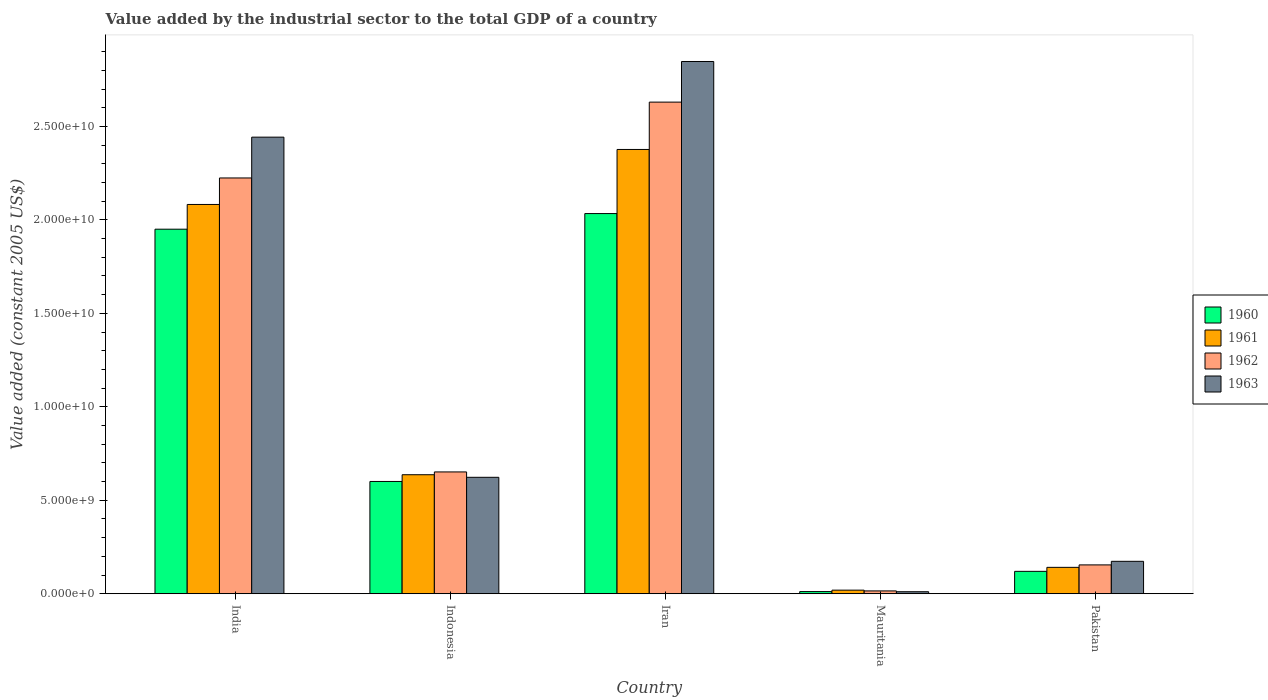Are the number of bars per tick equal to the number of legend labels?
Ensure brevity in your answer.  Yes. Are the number of bars on each tick of the X-axis equal?
Ensure brevity in your answer.  Yes. How many bars are there on the 3rd tick from the left?
Provide a succinct answer. 4. In how many cases, is the number of bars for a given country not equal to the number of legend labels?
Give a very brief answer. 0. What is the value added by the industrial sector in 1962 in India?
Make the answer very short. 2.22e+1. Across all countries, what is the maximum value added by the industrial sector in 1962?
Your response must be concise. 2.63e+1. Across all countries, what is the minimum value added by the industrial sector in 1960?
Keep it short and to the point. 1.15e+08. In which country was the value added by the industrial sector in 1962 maximum?
Keep it short and to the point. Iran. In which country was the value added by the industrial sector in 1960 minimum?
Ensure brevity in your answer.  Mauritania. What is the total value added by the industrial sector in 1961 in the graph?
Offer a very short reply. 5.26e+1. What is the difference between the value added by the industrial sector in 1963 in Mauritania and that in Pakistan?
Provide a short and direct response. -1.63e+09. What is the difference between the value added by the industrial sector in 1962 in India and the value added by the industrial sector in 1963 in Pakistan?
Provide a short and direct response. 2.05e+1. What is the average value added by the industrial sector in 1961 per country?
Your answer should be compact. 1.05e+1. What is the difference between the value added by the industrial sector of/in 1960 and value added by the industrial sector of/in 1962 in Pakistan?
Your answer should be very brief. -3.45e+08. In how many countries, is the value added by the industrial sector in 1963 greater than 1000000000 US$?
Your answer should be very brief. 4. What is the ratio of the value added by the industrial sector in 1963 in Indonesia to that in Pakistan?
Make the answer very short. 3.59. What is the difference between the highest and the second highest value added by the industrial sector in 1961?
Your response must be concise. -2.94e+09. What is the difference between the highest and the lowest value added by the industrial sector in 1961?
Offer a very short reply. 2.36e+1. What does the 4th bar from the right in Indonesia represents?
Provide a short and direct response. 1960. Is it the case that in every country, the sum of the value added by the industrial sector in 1960 and value added by the industrial sector in 1962 is greater than the value added by the industrial sector in 1961?
Give a very brief answer. Yes. Are all the bars in the graph horizontal?
Offer a very short reply. No. How many countries are there in the graph?
Your response must be concise. 5. Does the graph contain any zero values?
Your response must be concise. No. Does the graph contain grids?
Make the answer very short. No. Where does the legend appear in the graph?
Ensure brevity in your answer.  Center right. How many legend labels are there?
Offer a very short reply. 4. What is the title of the graph?
Your response must be concise. Value added by the industrial sector to the total GDP of a country. What is the label or title of the Y-axis?
Offer a very short reply. Value added (constant 2005 US$). What is the Value added (constant 2005 US$) in 1960 in India?
Your response must be concise. 1.95e+1. What is the Value added (constant 2005 US$) of 1961 in India?
Your answer should be compact. 2.08e+1. What is the Value added (constant 2005 US$) of 1962 in India?
Ensure brevity in your answer.  2.22e+1. What is the Value added (constant 2005 US$) in 1963 in India?
Offer a terse response. 2.44e+1. What is the Value added (constant 2005 US$) of 1960 in Indonesia?
Provide a short and direct response. 6.01e+09. What is the Value added (constant 2005 US$) in 1961 in Indonesia?
Keep it short and to the point. 6.37e+09. What is the Value added (constant 2005 US$) in 1962 in Indonesia?
Provide a short and direct response. 6.52e+09. What is the Value added (constant 2005 US$) of 1963 in Indonesia?
Your answer should be very brief. 6.23e+09. What is the Value added (constant 2005 US$) in 1960 in Iran?
Your answer should be compact. 2.03e+1. What is the Value added (constant 2005 US$) in 1961 in Iran?
Provide a short and direct response. 2.38e+1. What is the Value added (constant 2005 US$) of 1962 in Iran?
Your response must be concise. 2.63e+1. What is the Value added (constant 2005 US$) of 1963 in Iran?
Keep it short and to the point. 2.85e+1. What is the Value added (constant 2005 US$) of 1960 in Mauritania?
Make the answer very short. 1.15e+08. What is the Value added (constant 2005 US$) in 1961 in Mauritania?
Your answer should be very brief. 1.92e+08. What is the Value added (constant 2005 US$) of 1962 in Mauritania?
Make the answer very short. 1.51e+08. What is the Value added (constant 2005 US$) in 1963 in Mauritania?
Keep it short and to the point. 1.08e+08. What is the Value added (constant 2005 US$) of 1960 in Pakistan?
Keep it short and to the point. 1.20e+09. What is the Value added (constant 2005 US$) of 1961 in Pakistan?
Make the answer very short. 1.41e+09. What is the Value added (constant 2005 US$) of 1962 in Pakistan?
Offer a very short reply. 1.54e+09. What is the Value added (constant 2005 US$) of 1963 in Pakistan?
Your response must be concise. 1.74e+09. Across all countries, what is the maximum Value added (constant 2005 US$) of 1960?
Offer a very short reply. 2.03e+1. Across all countries, what is the maximum Value added (constant 2005 US$) in 1961?
Your response must be concise. 2.38e+1. Across all countries, what is the maximum Value added (constant 2005 US$) in 1962?
Provide a succinct answer. 2.63e+1. Across all countries, what is the maximum Value added (constant 2005 US$) of 1963?
Provide a short and direct response. 2.85e+1. Across all countries, what is the minimum Value added (constant 2005 US$) in 1960?
Your answer should be compact. 1.15e+08. Across all countries, what is the minimum Value added (constant 2005 US$) in 1961?
Keep it short and to the point. 1.92e+08. Across all countries, what is the minimum Value added (constant 2005 US$) of 1962?
Make the answer very short. 1.51e+08. Across all countries, what is the minimum Value added (constant 2005 US$) of 1963?
Make the answer very short. 1.08e+08. What is the total Value added (constant 2005 US$) in 1960 in the graph?
Provide a short and direct response. 4.72e+1. What is the total Value added (constant 2005 US$) in 1961 in the graph?
Your answer should be compact. 5.26e+1. What is the total Value added (constant 2005 US$) in 1962 in the graph?
Provide a succinct answer. 5.68e+1. What is the total Value added (constant 2005 US$) in 1963 in the graph?
Provide a short and direct response. 6.10e+1. What is the difference between the Value added (constant 2005 US$) in 1960 in India and that in Indonesia?
Provide a short and direct response. 1.35e+1. What is the difference between the Value added (constant 2005 US$) in 1961 in India and that in Indonesia?
Your response must be concise. 1.45e+1. What is the difference between the Value added (constant 2005 US$) in 1962 in India and that in Indonesia?
Your answer should be very brief. 1.57e+1. What is the difference between the Value added (constant 2005 US$) of 1963 in India and that in Indonesia?
Make the answer very short. 1.82e+1. What is the difference between the Value added (constant 2005 US$) of 1960 in India and that in Iran?
Your answer should be compact. -8.36e+08. What is the difference between the Value added (constant 2005 US$) in 1961 in India and that in Iran?
Provide a succinct answer. -2.94e+09. What is the difference between the Value added (constant 2005 US$) in 1962 in India and that in Iran?
Offer a terse response. -4.06e+09. What is the difference between the Value added (constant 2005 US$) of 1963 in India and that in Iran?
Offer a very short reply. -4.05e+09. What is the difference between the Value added (constant 2005 US$) of 1960 in India and that in Mauritania?
Your answer should be compact. 1.94e+1. What is the difference between the Value added (constant 2005 US$) in 1961 in India and that in Mauritania?
Your answer should be compact. 2.06e+1. What is the difference between the Value added (constant 2005 US$) in 1962 in India and that in Mauritania?
Give a very brief answer. 2.21e+1. What is the difference between the Value added (constant 2005 US$) of 1963 in India and that in Mauritania?
Ensure brevity in your answer.  2.43e+1. What is the difference between the Value added (constant 2005 US$) in 1960 in India and that in Pakistan?
Ensure brevity in your answer.  1.83e+1. What is the difference between the Value added (constant 2005 US$) of 1961 in India and that in Pakistan?
Your answer should be compact. 1.94e+1. What is the difference between the Value added (constant 2005 US$) in 1962 in India and that in Pakistan?
Ensure brevity in your answer.  2.07e+1. What is the difference between the Value added (constant 2005 US$) in 1963 in India and that in Pakistan?
Your response must be concise. 2.27e+1. What is the difference between the Value added (constant 2005 US$) in 1960 in Indonesia and that in Iran?
Make the answer very short. -1.43e+1. What is the difference between the Value added (constant 2005 US$) of 1961 in Indonesia and that in Iran?
Ensure brevity in your answer.  -1.74e+1. What is the difference between the Value added (constant 2005 US$) in 1962 in Indonesia and that in Iran?
Ensure brevity in your answer.  -1.98e+1. What is the difference between the Value added (constant 2005 US$) in 1963 in Indonesia and that in Iran?
Your answer should be very brief. -2.22e+1. What is the difference between the Value added (constant 2005 US$) of 1960 in Indonesia and that in Mauritania?
Keep it short and to the point. 5.89e+09. What is the difference between the Value added (constant 2005 US$) in 1961 in Indonesia and that in Mauritania?
Give a very brief answer. 6.17e+09. What is the difference between the Value added (constant 2005 US$) of 1962 in Indonesia and that in Mauritania?
Keep it short and to the point. 6.37e+09. What is the difference between the Value added (constant 2005 US$) of 1963 in Indonesia and that in Mauritania?
Your answer should be very brief. 6.12e+09. What is the difference between the Value added (constant 2005 US$) in 1960 in Indonesia and that in Pakistan?
Ensure brevity in your answer.  4.81e+09. What is the difference between the Value added (constant 2005 US$) of 1961 in Indonesia and that in Pakistan?
Keep it short and to the point. 4.96e+09. What is the difference between the Value added (constant 2005 US$) of 1962 in Indonesia and that in Pakistan?
Keep it short and to the point. 4.97e+09. What is the difference between the Value added (constant 2005 US$) in 1963 in Indonesia and that in Pakistan?
Ensure brevity in your answer.  4.49e+09. What is the difference between the Value added (constant 2005 US$) in 1960 in Iran and that in Mauritania?
Give a very brief answer. 2.02e+1. What is the difference between the Value added (constant 2005 US$) of 1961 in Iran and that in Mauritania?
Ensure brevity in your answer.  2.36e+1. What is the difference between the Value added (constant 2005 US$) of 1962 in Iran and that in Mauritania?
Your answer should be very brief. 2.62e+1. What is the difference between the Value added (constant 2005 US$) of 1963 in Iran and that in Mauritania?
Offer a terse response. 2.84e+1. What is the difference between the Value added (constant 2005 US$) of 1960 in Iran and that in Pakistan?
Ensure brevity in your answer.  1.91e+1. What is the difference between the Value added (constant 2005 US$) of 1961 in Iran and that in Pakistan?
Give a very brief answer. 2.24e+1. What is the difference between the Value added (constant 2005 US$) in 1962 in Iran and that in Pakistan?
Your answer should be very brief. 2.48e+1. What is the difference between the Value added (constant 2005 US$) of 1963 in Iran and that in Pakistan?
Provide a succinct answer. 2.67e+1. What is the difference between the Value added (constant 2005 US$) of 1960 in Mauritania and that in Pakistan?
Offer a very short reply. -1.08e+09. What is the difference between the Value added (constant 2005 US$) of 1961 in Mauritania and that in Pakistan?
Your response must be concise. -1.22e+09. What is the difference between the Value added (constant 2005 US$) in 1962 in Mauritania and that in Pakistan?
Make the answer very short. -1.39e+09. What is the difference between the Value added (constant 2005 US$) in 1963 in Mauritania and that in Pakistan?
Your response must be concise. -1.63e+09. What is the difference between the Value added (constant 2005 US$) of 1960 in India and the Value added (constant 2005 US$) of 1961 in Indonesia?
Provide a succinct answer. 1.31e+1. What is the difference between the Value added (constant 2005 US$) in 1960 in India and the Value added (constant 2005 US$) in 1962 in Indonesia?
Offer a very short reply. 1.30e+1. What is the difference between the Value added (constant 2005 US$) in 1960 in India and the Value added (constant 2005 US$) in 1963 in Indonesia?
Make the answer very short. 1.33e+1. What is the difference between the Value added (constant 2005 US$) of 1961 in India and the Value added (constant 2005 US$) of 1962 in Indonesia?
Provide a succinct answer. 1.43e+1. What is the difference between the Value added (constant 2005 US$) of 1961 in India and the Value added (constant 2005 US$) of 1963 in Indonesia?
Make the answer very short. 1.46e+1. What is the difference between the Value added (constant 2005 US$) in 1962 in India and the Value added (constant 2005 US$) in 1963 in Indonesia?
Your answer should be very brief. 1.60e+1. What is the difference between the Value added (constant 2005 US$) of 1960 in India and the Value added (constant 2005 US$) of 1961 in Iran?
Provide a short and direct response. -4.27e+09. What is the difference between the Value added (constant 2005 US$) in 1960 in India and the Value added (constant 2005 US$) in 1962 in Iran?
Provide a short and direct response. -6.80e+09. What is the difference between the Value added (constant 2005 US$) of 1960 in India and the Value added (constant 2005 US$) of 1963 in Iran?
Make the answer very short. -8.97e+09. What is the difference between the Value added (constant 2005 US$) of 1961 in India and the Value added (constant 2005 US$) of 1962 in Iran?
Your answer should be very brief. -5.48e+09. What is the difference between the Value added (constant 2005 US$) in 1961 in India and the Value added (constant 2005 US$) in 1963 in Iran?
Your response must be concise. -7.65e+09. What is the difference between the Value added (constant 2005 US$) of 1962 in India and the Value added (constant 2005 US$) of 1963 in Iran?
Offer a very short reply. -6.23e+09. What is the difference between the Value added (constant 2005 US$) in 1960 in India and the Value added (constant 2005 US$) in 1961 in Mauritania?
Your answer should be very brief. 1.93e+1. What is the difference between the Value added (constant 2005 US$) of 1960 in India and the Value added (constant 2005 US$) of 1962 in Mauritania?
Give a very brief answer. 1.94e+1. What is the difference between the Value added (constant 2005 US$) in 1960 in India and the Value added (constant 2005 US$) in 1963 in Mauritania?
Offer a terse response. 1.94e+1. What is the difference between the Value added (constant 2005 US$) in 1961 in India and the Value added (constant 2005 US$) in 1962 in Mauritania?
Offer a terse response. 2.07e+1. What is the difference between the Value added (constant 2005 US$) in 1961 in India and the Value added (constant 2005 US$) in 1963 in Mauritania?
Offer a terse response. 2.07e+1. What is the difference between the Value added (constant 2005 US$) in 1962 in India and the Value added (constant 2005 US$) in 1963 in Mauritania?
Make the answer very short. 2.21e+1. What is the difference between the Value added (constant 2005 US$) of 1960 in India and the Value added (constant 2005 US$) of 1961 in Pakistan?
Ensure brevity in your answer.  1.81e+1. What is the difference between the Value added (constant 2005 US$) in 1960 in India and the Value added (constant 2005 US$) in 1962 in Pakistan?
Offer a very short reply. 1.80e+1. What is the difference between the Value added (constant 2005 US$) in 1960 in India and the Value added (constant 2005 US$) in 1963 in Pakistan?
Keep it short and to the point. 1.78e+1. What is the difference between the Value added (constant 2005 US$) of 1961 in India and the Value added (constant 2005 US$) of 1962 in Pakistan?
Make the answer very short. 1.93e+1. What is the difference between the Value added (constant 2005 US$) of 1961 in India and the Value added (constant 2005 US$) of 1963 in Pakistan?
Ensure brevity in your answer.  1.91e+1. What is the difference between the Value added (constant 2005 US$) in 1962 in India and the Value added (constant 2005 US$) in 1963 in Pakistan?
Your answer should be very brief. 2.05e+1. What is the difference between the Value added (constant 2005 US$) in 1960 in Indonesia and the Value added (constant 2005 US$) in 1961 in Iran?
Make the answer very short. -1.78e+1. What is the difference between the Value added (constant 2005 US$) of 1960 in Indonesia and the Value added (constant 2005 US$) of 1962 in Iran?
Your answer should be very brief. -2.03e+1. What is the difference between the Value added (constant 2005 US$) in 1960 in Indonesia and the Value added (constant 2005 US$) in 1963 in Iran?
Ensure brevity in your answer.  -2.25e+1. What is the difference between the Value added (constant 2005 US$) of 1961 in Indonesia and the Value added (constant 2005 US$) of 1962 in Iran?
Offer a terse response. -1.99e+1. What is the difference between the Value added (constant 2005 US$) of 1961 in Indonesia and the Value added (constant 2005 US$) of 1963 in Iran?
Make the answer very short. -2.21e+1. What is the difference between the Value added (constant 2005 US$) of 1962 in Indonesia and the Value added (constant 2005 US$) of 1963 in Iran?
Offer a terse response. -2.20e+1. What is the difference between the Value added (constant 2005 US$) in 1960 in Indonesia and the Value added (constant 2005 US$) in 1961 in Mauritania?
Ensure brevity in your answer.  5.81e+09. What is the difference between the Value added (constant 2005 US$) of 1960 in Indonesia and the Value added (constant 2005 US$) of 1962 in Mauritania?
Provide a succinct answer. 5.86e+09. What is the difference between the Value added (constant 2005 US$) in 1960 in Indonesia and the Value added (constant 2005 US$) in 1963 in Mauritania?
Your response must be concise. 5.90e+09. What is the difference between the Value added (constant 2005 US$) in 1961 in Indonesia and the Value added (constant 2005 US$) in 1962 in Mauritania?
Ensure brevity in your answer.  6.22e+09. What is the difference between the Value added (constant 2005 US$) of 1961 in Indonesia and the Value added (constant 2005 US$) of 1963 in Mauritania?
Provide a short and direct response. 6.26e+09. What is the difference between the Value added (constant 2005 US$) in 1962 in Indonesia and the Value added (constant 2005 US$) in 1963 in Mauritania?
Provide a short and direct response. 6.41e+09. What is the difference between the Value added (constant 2005 US$) in 1960 in Indonesia and the Value added (constant 2005 US$) in 1961 in Pakistan?
Your response must be concise. 4.60e+09. What is the difference between the Value added (constant 2005 US$) of 1960 in Indonesia and the Value added (constant 2005 US$) of 1962 in Pakistan?
Give a very brief answer. 4.46e+09. What is the difference between the Value added (constant 2005 US$) in 1960 in Indonesia and the Value added (constant 2005 US$) in 1963 in Pakistan?
Your response must be concise. 4.27e+09. What is the difference between the Value added (constant 2005 US$) of 1961 in Indonesia and the Value added (constant 2005 US$) of 1962 in Pakistan?
Give a very brief answer. 4.82e+09. What is the difference between the Value added (constant 2005 US$) in 1961 in Indonesia and the Value added (constant 2005 US$) in 1963 in Pakistan?
Give a very brief answer. 4.63e+09. What is the difference between the Value added (constant 2005 US$) of 1962 in Indonesia and the Value added (constant 2005 US$) of 1963 in Pakistan?
Give a very brief answer. 4.78e+09. What is the difference between the Value added (constant 2005 US$) in 1960 in Iran and the Value added (constant 2005 US$) in 1961 in Mauritania?
Provide a succinct answer. 2.01e+1. What is the difference between the Value added (constant 2005 US$) of 1960 in Iran and the Value added (constant 2005 US$) of 1962 in Mauritania?
Ensure brevity in your answer.  2.02e+1. What is the difference between the Value added (constant 2005 US$) in 1960 in Iran and the Value added (constant 2005 US$) in 1963 in Mauritania?
Offer a very short reply. 2.02e+1. What is the difference between the Value added (constant 2005 US$) in 1961 in Iran and the Value added (constant 2005 US$) in 1962 in Mauritania?
Provide a succinct answer. 2.36e+1. What is the difference between the Value added (constant 2005 US$) of 1961 in Iran and the Value added (constant 2005 US$) of 1963 in Mauritania?
Your answer should be compact. 2.37e+1. What is the difference between the Value added (constant 2005 US$) of 1962 in Iran and the Value added (constant 2005 US$) of 1963 in Mauritania?
Keep it short and to the point. 2.62e+1. What is the difference between the Value added (constant 2005 US$) in 1960 in Iran and the Value added (constant 2005 US$) in 1961 in Pakistan?
Keep it short and to the point. 1.89e+1. What is the difference between the Value added (constant 2005 US$) in 1960 in Iran and the Value added (constant 2005 US$) in 1962 in Pakistan?
Your response must be concise. 1.88e+1. What is the difference between the Value added (constant 2005 US$) of 1960 in Iran and the Value added (constant 2005 US$) of 1963 in Pakistan?
Make the answer very short. 1.86e+1. What is the difference between the Value added (constant 2005 US$) in 1961 in Iran and the Value added (constant 2005 US$) in 1962 in Pakistan?
Give a very brief answer. 2.22e+1. What is the difference between the Value added (constant 2005 US$) in 1961 in Iran and the Value added (constant 2005 US$) in 1963 in Pakistan?
Make the answer very short. 2.20e+1. What is the difference between the Value added (constant 2005 US$) in 1962 in Iran and the Value added (constant 2005 US$) in 1963 in Pakistan?
Offer a terse response. 2.46e+1. What is the difference between the Value added (constant 2005 US$) in 1960 in Mauritania and the Value added (constant 2005 US$) in 1961 in Pakistan?
Keep it short and to the point. -1.30e+09. What is the difference between the Value added (constant 2005 US$) of 1960 in Mauritania and the Value added (constant 2005 US$) of 1962 in Pakistan?
Offer a terse response. -1.43e+09. What is the difference between the Value added (constant 2005 US$) of 1960 in Mauritania and the Value added (constant 2005 US$) of 1963 in Pakistan?
Provide a short and direct response. -1.62e+09. What is the difference between the Value added (constant 2005 US$) of 1961 in Mauritania and the Value added (constant 2005 US$) of 1962 in Pakistan?
Provide a succinct answer. -1.35e+09. What is the difference between the Value added (constant 2005 US$) of 1961 in Mauritania and the Value added (constant 2005 US$) of 1963 in Pakistan?
Offer a terse response. -1.54e+09. What is the difference between the Value added (constant 2005 US$) of 1962 in Mauritania and the Value added (constant 2005 US$) of 1963 in Pakistan?
Keep it short and to the point. -1.58e+09. What is the average Value added (constant 2005 US$) of 1960 per country?
Provide a short and direct response. 9.43e+09. What is the average Value added (constant 2005 US$) of 1961 per country?
Offer a terse response. 1.05e+1. What is the average Value added (constant 2005 US$) in 1962 per country?
Give a very brief answer. 1.14e+1. What is the average Value added (constant 2005 US$) in 1963 per country?
Provide a short and direct response. 1.22e+1. What is the difference between the Value added (constant 2005 US$) of 1960 and Value added (constant 2005 US$) of 1961 in India?
Offer a very short reply. -1.32e+09. What is the difference between the Value added (constant 2005 US$) in 1960 and Value added (constant 2005 US$) in 1962 in India?
Keep it short and to the point. -2.74e+09. What is the difference between the Value added (constant 2005 US$) in 1960 and Value added (constant 2005 US$) in 1963 in India?
Give a very brief answer. -4.92e+09. What is the difference between the Value added (constant 2005 US$) of 1961 and Value added (constant 2005 US$) of 1962 in India?
Give a very brief answer. -1.42e+09. What is the difference between the Value added (constant 2005 US$) of 1961 and Value added (constant 2005 US$) of 1963 in India?
Keep it short and to the point. -3.60e+09. What is the difference between the Value added (constant 2005 US$) of 1962 and Value added (constant 2005 US$) of 1963 in India?
Provide a succinct answer. -2.18e+09. What is the difference between the Value added (constant 2005 US$) of 1960 and Value added (constant 2005 US$) of 1961 in Indonesia?
Keep it short and to the point. -3.60e+08. What is the difference between the Value added (constant 2005 US$) of 1960 and Value added (constant 2005 US$) of 1962 in Indonesia?
Offer a very short reply. -5.10e+08. What is the difference between the Value added (constant 2005 US$) in 1960 and Value added (constant 2005 US$) in 1963 in Indonesia?
Your answer should be very brief. -2.22e+08. What is the difference between the Value added (constant 2005 US$) in 1961 and Value added (constant 2005 US$) in 1962 in Indonesia?
Offer a very short reply. -1.50e+08. What is the difference between the Value added (constant 2005 US$) of 1961 and Value added (constant 2005 US$) of 1963 in Indonesia?
Your answer should be compact. 1.38e+08. What is the difference between the Value added (constant 2005 US$) of 1962 and Value added (constant 2005 US$) of 1963 in Indonesia?
Give a very brief answer. 2.88e+08. What is the difference between the Value added (constant 2005 US$) in 1960 and Value added (constant 2005 US$) in 1961 in Iran?
Give a very brief answer. -3.43e+09. What is the difference between the Value added (constant 2005 US$) of 1960 and Value added (constant 2005 US$) of 1962 in Iran?
Provide a succinct answer. -5.96e+09. What is the difference between the Value added (constant 2005 US$) of 1960 and Value added (constant 2005 US$) of 1963 in Iran?
Provide a short and direct response. -8.14e+09. What is the difference between the Value added (constant 2005 US$) in 1961 and Value added (constant 2005 US$) in 1962 in Iran?
Make the answer very short. -2.53e+09. What is the difference between the Value added (constant 2005 US$) of 1961 and Value added (constant 2005 US$) of 1963 in Iran?
Your response must be concise. -4.71e+09. What is the difference between the Value added (constant 2005 US$) of 1962 and Value added (constant 2005 US$) of 1963 in Iran?
Ensure brevity in your answer.  -2.17e+09. What is the difference between the Value added (constant 2005 US$) of 1960 and Value added (constant 2005 US$) of 1961 in Mauritania?
Keep it short and to the point. -7.68e+07. What is the difference between the Value added (constant 2005 US$) of 1960 and Value added (constant 2005 US$) of 1962 in Mauritania?
Give a very brief answer. -3.59e+07. What is the difference between the Value added (constant 2005 US$) of 1960 and Value added (constant 2005 US$) of 1963 in Mauritania?
Ensure brevity in your answer.  7.13e+06. What is the difference between the Value added (constant 2005 US$) in 1961 and Value added (constant 2005 US$) in 1962 in Mauritania?
Your answer should be very brief. 4.09e+07. What is the difference between the Value added (constant 2005 US$) of 1961 and Value added (constant 2005 US$) of 1963 in Mauritania?
Offer a terse response. 8.39e+07. What is the difference between the Value added (constant 2005 US$) in 1962 and Value added (constant 2005 US$) in 1963 in Mauritania?
Offer a very short reply. 4.31e+07. What is the difference between the Value added (constant 2005 US$) of 1960 and Value added (constant 2005 US$) of 1961 in Pakistan?
Provide a succinct answer. -2.14e+08. What is the difference between the Value added (constant 2005 US$) in 1960 and Value added (constant 2005 US$) in 1962 in Pakistan?
Provide a succinct answer. -3.45e+08. What is the difference between the Value added (constant 2005 US$) of 1960 and Value added (constant 2005 US$) of 1963 in Pakistan?
Offer a terse response. -5.37e+08. What is the difference between the Value added (constant 2005 US$) of 1961 and Value added (constant 2005 US$) of 1962 in Pakistan?
Your response must be concise. -1.32e+08. What is the difference between the Value added (constant 2005 US$) of 1961 and Value added (constant 2005 US$) of 1963 in Pakistan?
Provide a succinct answer. -3.23e+08. What is the difference between the Value added (constant 2005 US$) in 1962 and Value added (constant 2005 US$) in 1963 in Pakistan?
Give a very brief answer. -1.92e+08. What is the ratio of the Value added (constant 2005 US$) of 1960 in India to that in Indonesia?
Offer a very short reply. 3.25. What is the ratio of the Value added (constant 2005 US$) of 1961 in India to that in Indonesia?
Make the answer very short. 3.27. What is the ratio of the Value added (constant 2005 US$) in 1962 in India to that in Indonesia?
Your answer should be compact. 3.41. What is the ratio of the Value added (constant 2005 US$) of 1963 in India to that in Indonesia?
Make the answer very short. 3.92. What is the ratio of the Value added (constant 2005 US$) of 1960 in India to that in Iran?
Ensure brevity in your answer.  0.96. What is the ratio of the Value added (constant 2005 US$) of 1961 in India to that in Iran?
Ensure brevity in your answer.  0.88. What is the ratio of the Value added (constant 2005 US$) in 1962 in India to that in Iran?
Provide a succinct answer. 0.85. What is the ratio of the Value added (constant 2005 US$) in 1963 in India to that in Iran?
Offer a very short reply. 0.86. What is the ratio of the Value added (constant 2005 US$) of 1960 in India to that in Mauritania?
Offer a terse response. 169.07. What is the ratio of the Value added (constant 2005 US$) of 1961 in India to that in Mauritania?
Provide a short and direct response. 108.39. What is the ratio of the Value added (constant 2005 US$) in 1962 in India to that in Mauritania?
Provide a short and direct response. 147.02. What is the ratio of the Value added (constant 2005 US$) in 1963 in India to that in Mauritania?
Ensure brevity in your answer.  225.7. What is the ratio of the Value added (constant 2005 US$) in 1960 in India to that in Pakistan?
Give a very brief answer. 16.28. What is the ratio of the Value added (constant 2005 US$) of 1961 in India to that in Pakistan?
Ensure brevity in your answer.  14.75. What is the ratio of the Value added (constant 2005 US$) in 1962 in India to that in Pakistan?
Provide a short and direct response. 14.41. What is the ratio of the Value added (constant 2005 US$) in 1963 in India to that in Pakistan?
Offer a terse response. 14.08. What is the ratio of the Value added (constant 2005 US$) in 1960 in Indonesia to that in Iran?
Offer a very short reply. 0.3. What is the ratio of the Value added (constant 2005 US$) in 1961 in Indonesia to that in Iran?
Your answer should be very brief. 0.27. What is the ratio of the Value added (constant 2005 US$) of 1962 in Indonesia to that in Iran?
Keep it short and to the point. 0.25. What is the ratio of the Value added (constant 2005 US$) of 1963 in Indonesia to that in Iran?
Keep it short and to the point. 0.22. What is the ratio of the Value added (constant 2005 US$) in 1960 in Indonesia to that in Mauritania?
Give a very brief answer. 52.07. What is the ratio of the Value added (constant 2005 US$) in 1961 in Indonesia to that in Mauritania?
Offer a very short reply. 33.14. What is the ratio of the Value added (constant 2005 US$) of 1962 in Indonesia to that in Mauritania?
Offer a terse response. 43.07. What is the ratio of the Value added (constant 2005 US$) in 1963 in Indonesia to that in Mauritania?
Make the answer very short. 57.56. What is the ratio of the Value added (constant 2005 US$) of 1960 in Indonesia to that in Pakistan?
Provide a short and direct response. 5.01. What is the ratio of the Value added (constant 2005 US$) in 1961 in Indonesia to that in Pakistan?
Make the answer very short. 4.51. What is the ratio of the Value added (constant 2005 US$) of 1962 in Indonesia to that in Pakistan?
Your answer should be very brief. 4.22. What is the ratio of the Value added (constant 2005 US$) of 1963 in Indonesia to that in Pakistan?
Make the answer very short. 3.59. What is the ratio of the Value added (constant 2005 US$) of 1960 in Iran to that in Mauritania?
Your answer should be very brief. 176.32. What is the ratio of the Value added (constant 2005 US$) in 1961 in Iran to that in Mauritania?
Your answer should be very brief. 123.7. What is the ratio of the Value added (constant 2005 US$) of 1962 in Iran to that in Mauritania?
Your answer should be compact. 173.84. What is the ratio of the Value added (constant 2005 US$) in 1963 in Iran to that in Mauritania?
Keep it short and to the point. 263.11. What is the ratio of the Value added (constant 2005 US$) in 1960 in Iran to that in Pakistan?
Provide a short and direct response. 16.98. What is the ratio of the Value added (constant 2005 US$) of 1961 in Iran to that in Pakistan?
Your response must be concise. 16.84. What is the ratio of the Value added (constant 2005 US$) of 1962 in Iran to that in Pakistan?
Your response must be concise. 17.04. What is the ratio of the Value added (constant 2005 US$) in 1963 in Iran to that in Pakistan?
Your answer should be compact. 16.41. What is the ratio of the Value added (constant 2005 US$) in 1960 in Mauritania to that in Pakistan?
Keep it short and to the point. 0.1. What is the ratio of the Value added (constant 2005 US$) in 1961 in Mauritania to that in Pakistan?
Make the answer very short. 0.14. What is the ratio of the Value added (constant 2005 US$) of 1962 in Mauritania to that in Pakistan?
Provide a short and direct response. 0.1. What is the ratio of the Value added (constant 2005 US$) of 1963 in Mauritania to that in Pakistan?
Your answer should be compact. 0.06. What is the difference between the highest and the second highest Value added (constant 2005 US$) in 1960?
Your response must be concise. 8.36e+08. What is the difference between the highest and the second highest Value added (constant 2005 US$) in 1961?
Your response must be concise. 2.94e+09. What is the difference between the highest and the second highest Value added (constant 2005 US$) in 1962?
Offer a very short reply. 4.06e+09. What is the difference between the highest and the second highest Value added (constant 2005 US$) in 1963?
Provide a succinct answer. 4.05e+09. What is the difference between the highest and the lowest Value added (constant 2005 US$) of 1960?
Keep it short and to the point. 2.02e+1. What is the difference between the highest and the lowest Value added (constant 2005 US$) of 1961?
Ensure brevity in your answer.  2.36e+1. What is the difference between the highest and the lowest Value added (constant 2005 US$) in 1962?
Make the answer very short. 2.62e+1. What is the difference between the highest and the lowest Value added (constant 2005 US$) of 1963?
Your answer should be compact. 2.84e+1. 